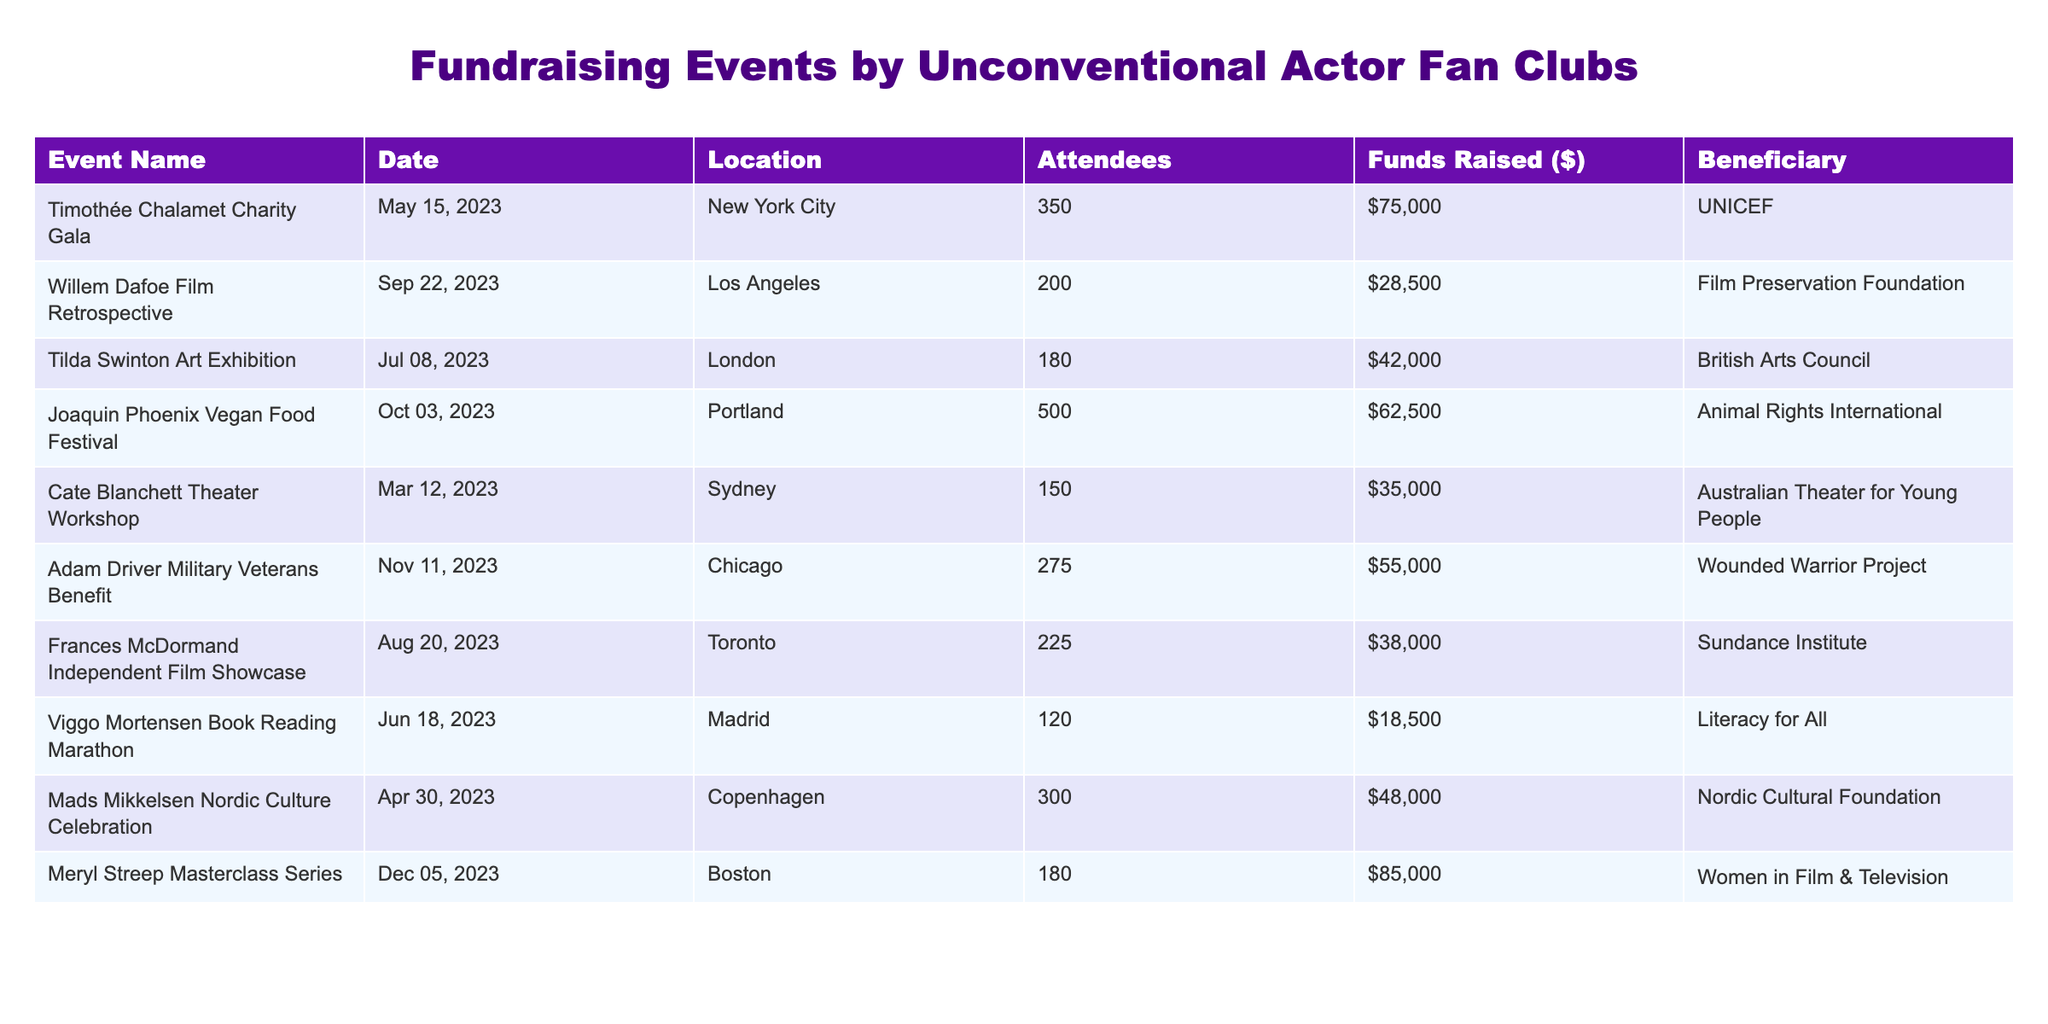What is the date of the Timothée Chalamet Charity Gala? The table lists the event name "Timothée Chalamet Charity Gala" with the corresponding date under the 'Date' column, which shows May 15, 2023.
Answer: May 15, 2023 How much money was raised at the Meryl Streep Masterclass Series? Referring to the 'Funds Raised ($)' column, the amount raised at the Meryl Streep Masterclass Series is shown as $85,000.
Answer: $85,000 Which event had the highest number of attendees? By comparing the 'Attendees' column, the Joaquin Phoenix Vegan Food Festival shows the highest figure at 500 attendees.
Answer: 500 Was the total amount raised at the Adam Driver Military Veterans Benefit greater than $50,000? The table indicates that the funds raised at the Adam Driver Military Veterans Benefit amounted to $55,000, which is indeed greater than $50,000.
Answer: Yes What was the average amount raised across all events? To find the average, first sum all funds raised: $75,000 + $28,500 + $42,000 + $62,500 + $35,000 + $55,000 + $38,000 + $18,500 + $48,000 + $85,000 = $438,500. Then, divide by the number of events (10): $438,500 / 10 = $43,850.
Answer: $43,850 Which beneficiary received the least amount of funds raised? Comparing the 'Beneficiary' and 'Funds Raised ($)' columns, the Film Preservation Foundation received the least at $28,500.
Answer: Film Preservation Foundation What percentage of funds raised from the Joaquin Phoenix Vegan Food Festival is greater than the amount raised from the Tilda Swinton Art Exhibition? The funds from the Joaquin Phoenix Vegan Food Festival are $62,500, while Tilda Swinton Art Exhibition raised $42,000. The difference is $62,500 - $42,000 = $20,500. To find the percentage: ($20,500 / $62,500) * 100 ≈ 32.8%.
Answer: Approximately 32.8% Which two events raised a combined total of exactly $200,000? Looking at the funds raised by each event, the sum of the Meryl Streep Masterclass Series ($85,000) and the Joaquin Phoenix Vegan Food Festival ($62,500) gives $147,500, which is not $200,000. However, if we take the Timothée Chalamet Charity Gala ($75,000) and Adam Driver Military Veterans Benefit ($55,000), we again do not reach $200,000. After checking combinations, the correct pair is the Meryl Streep Masterclass Series ($85,000) and the Adam Driver Military Veterans Benefit ($55,000) because together they total $140,000. So, no pair reaches exactly $200,000.
Answer: No pair reached exactly $200,000 